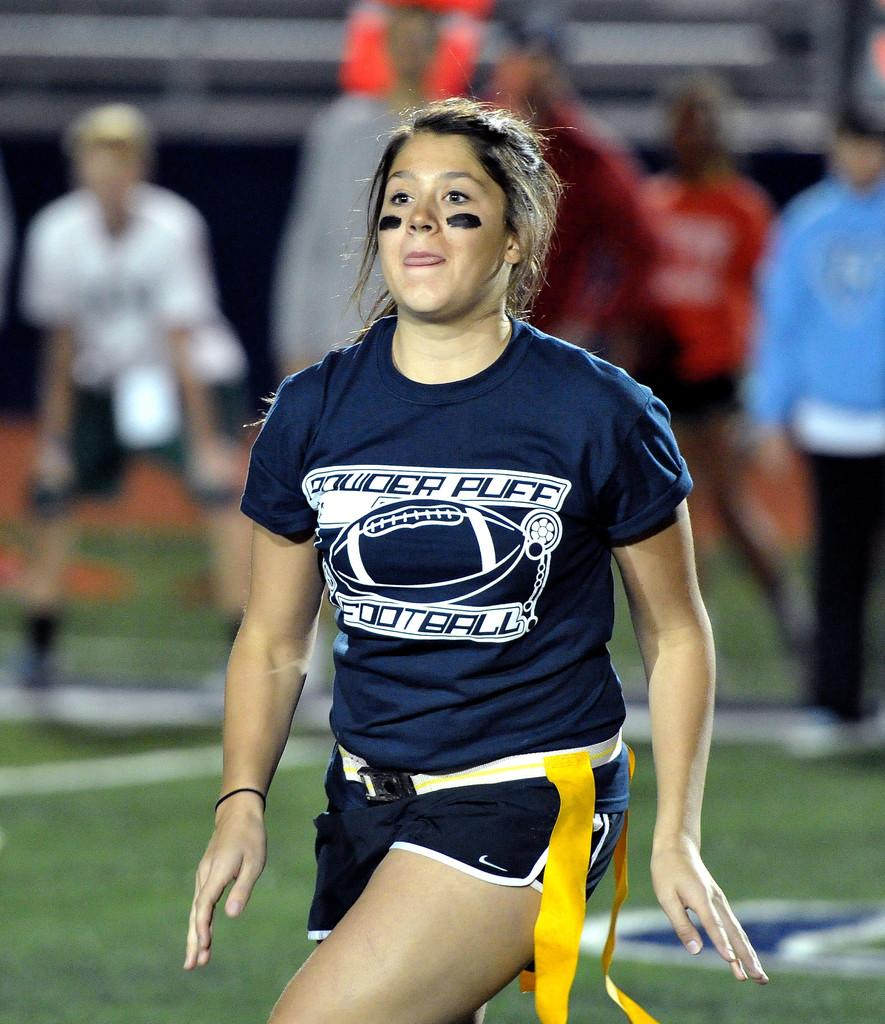<image>
Summarize the visual content of the image. A girl wearing a blue uniform with the word football on bottom of jersey. 